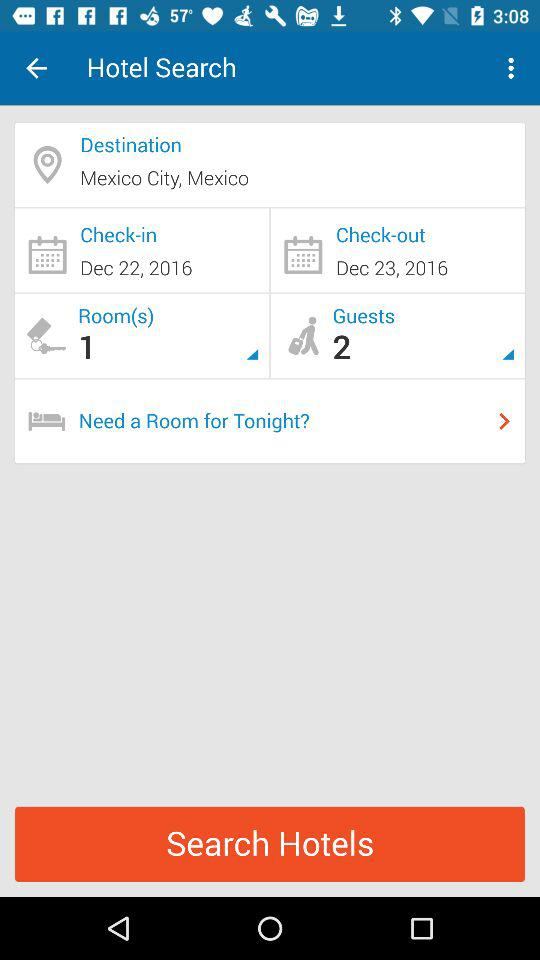How many rooms are selected? The selected number of rooms is 1. 